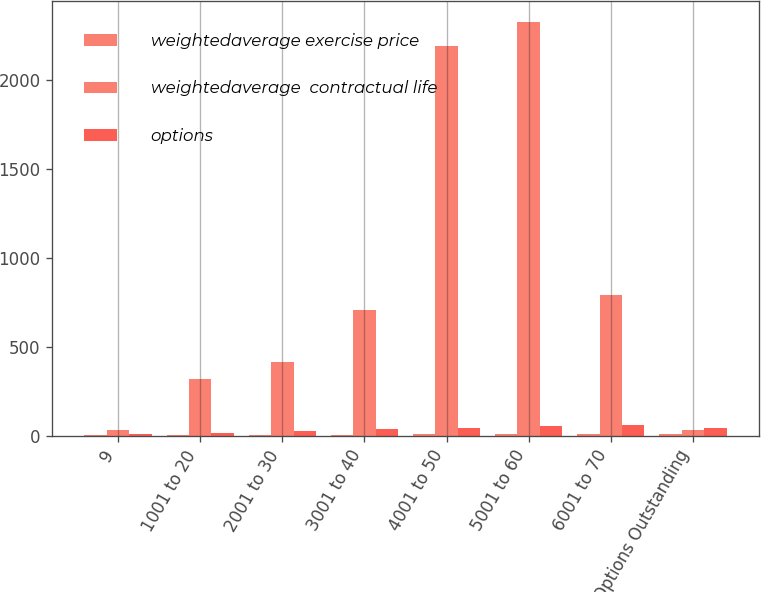Convert chart. <chart><loc_0><loc_0><loc_500><loc_500><stacked_bar_chart><ecel><fcel>9<fcel>1001 to 20<fcel>2001 to 30<fcel>3001 to 40<fcel>4001 to 50<fcel>5001 to 60<fcel>6001 to 70<fcel>Options Outstanding<nl><fcel>weightedaverage exercise price<fcel>0.1<fcel>1.9<fcel>3.2<fcel>4.3<fcel>6.5<fcel>7.3<fcel>9.1<fcel>6.3<nl><fcel>weightedaverage  contractual life<fcel>31<fcel>317<fcel>413<fcel>709<fcel>2194<fcel>2330<fcel>791<fcel>31<nl><fcel>options<fcel>9<fcel>13<fcel>26<fcel>35<fcel>42<fcel>52<fcel>61<fcel>45<nl></chart> 